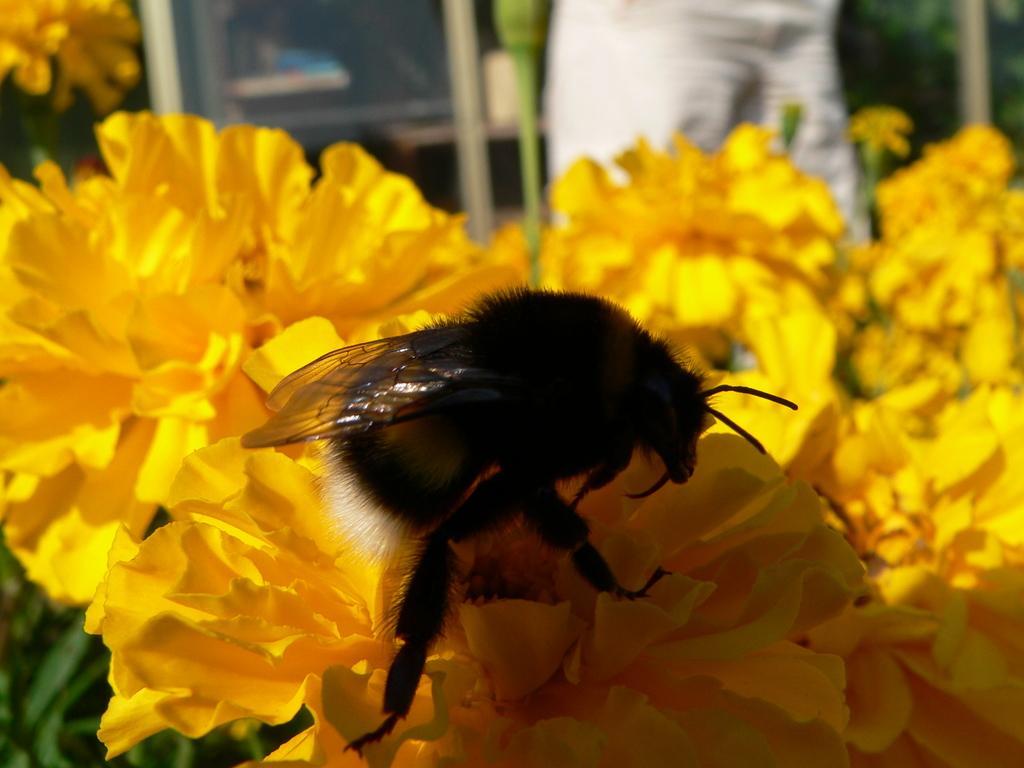Describe this image in one or two sentences. In this picture we can see insect on the yellow flowers. Here we can see plant. At the top we can see a person who is standing at the door. 